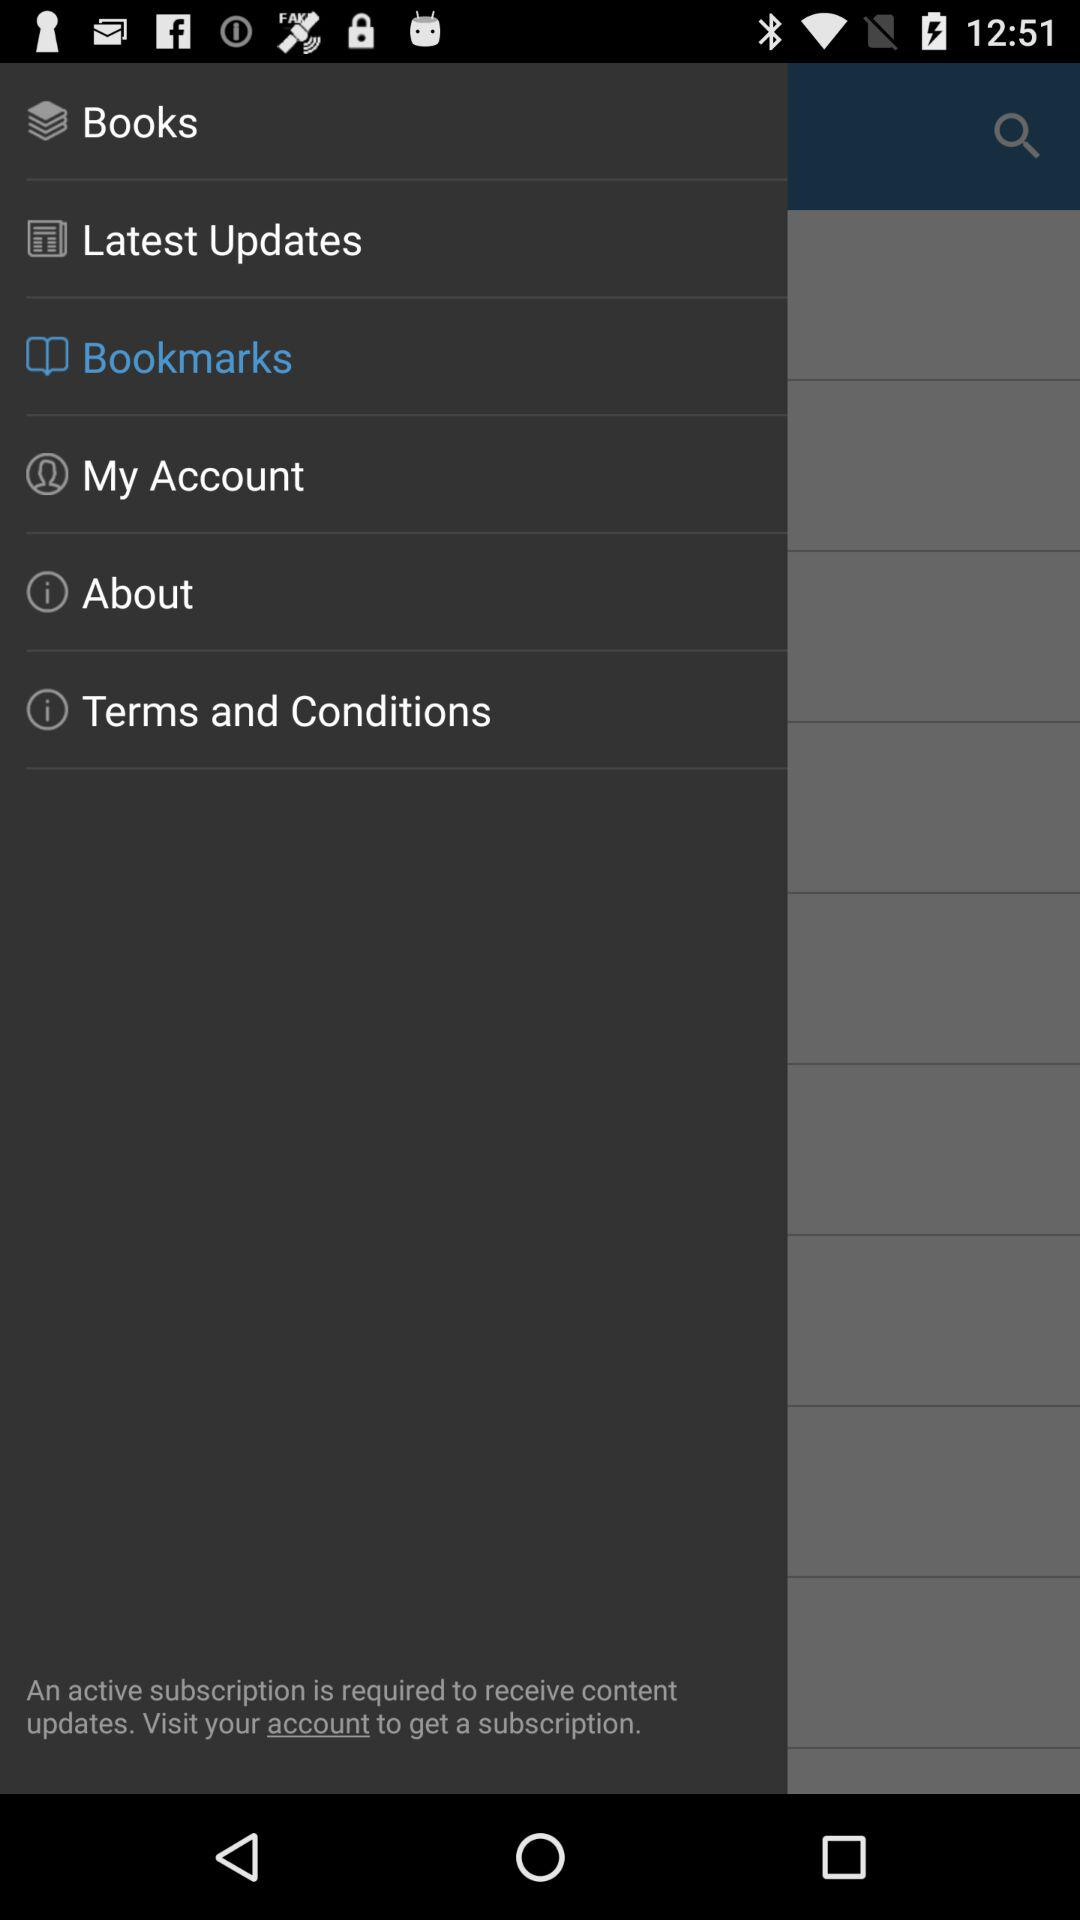Which books are saved by the user?
When the provided information is insufficient, respond with <no answer>. <no answer> 